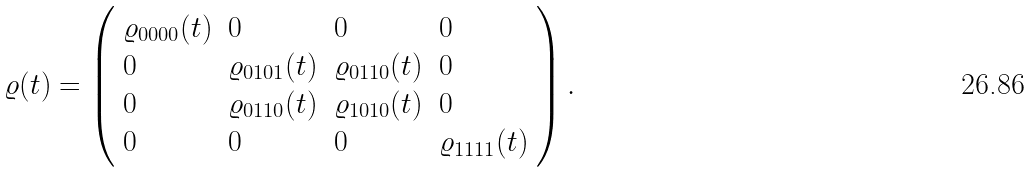Convert formula to latex. <formula><loc_0><loc_0><loc_500><loc_500>\varrho ( t ) = \left ( \begin{array} { l l l l } \varrho _ { 0 0 0 0 } ( t ) & 0 & 0 & 0 \\ 0 & \varrho _ { 0 1 0 1 } ( t ) & \varrho _ { 0 1 1 0 } ( t ) & 0 \\ 0 & \varrho _ { 0 1 1 0 } ( t ) & \varrho _ { 1 0 1 0 } ( t ) & 0 \\ 0 & 0 & 0 & \varrho _ { 1 1 1 1 } ( t ) \end{array} \right ) .</formula> 